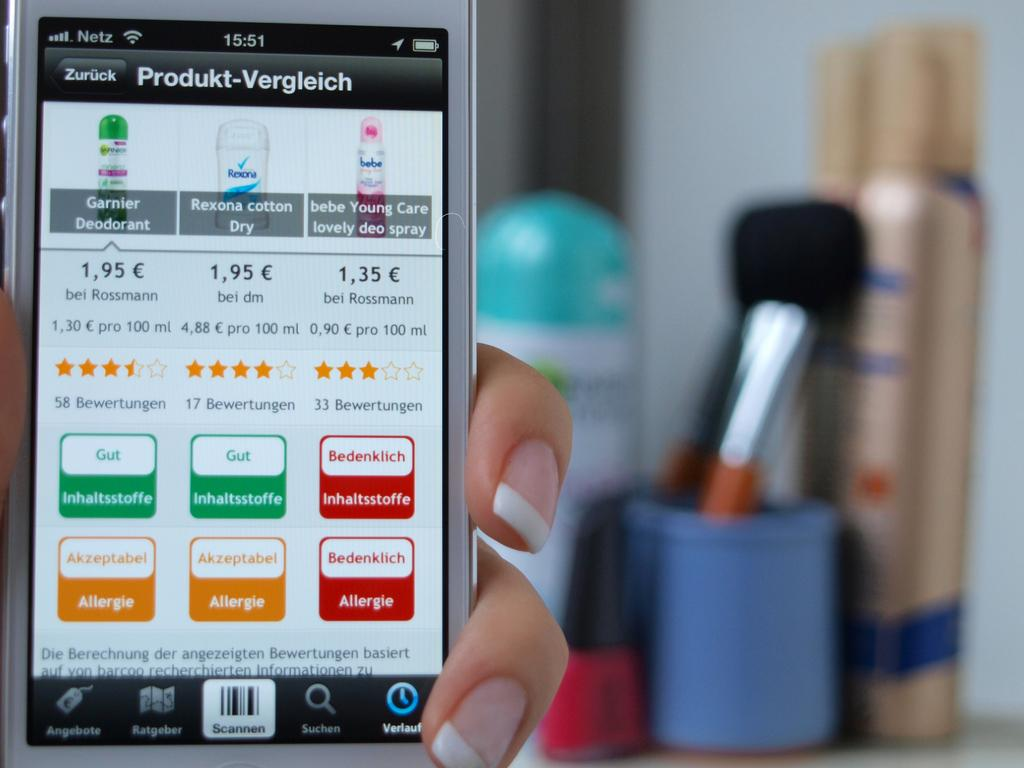Provide a one-sentence caption for the provided image. A phone that has a screen pulled up with various pricing and information about beauty products. 